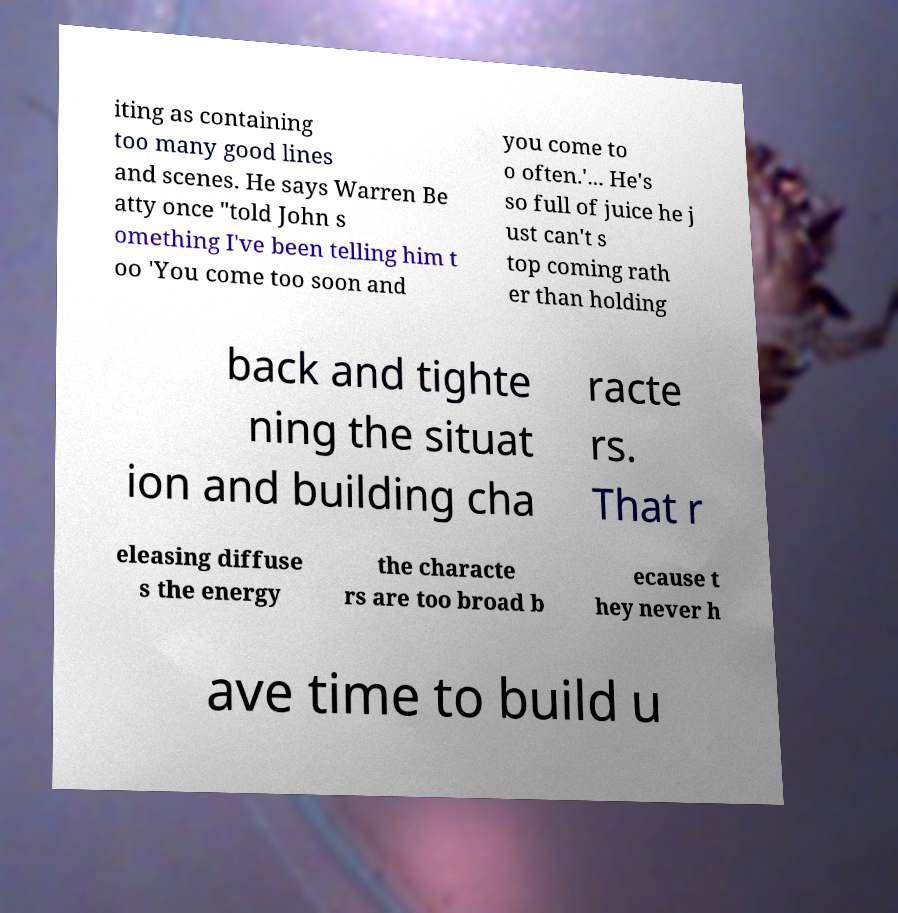Can you accurately transcribe the text from the provided image for me? iting as containing too many good lines and scenes. He says Warren Be atty once "told John s omething I've been telling him t oo 'You come too soon and you come to o often.'... He's so full of juice he j ust can't s top coming rath er than holding back and tighte ning the situat ion and building cha racte rs. That r eleasing diffuse s the energy the characte rs are too broad b ecause t hey never h ave time to build u 